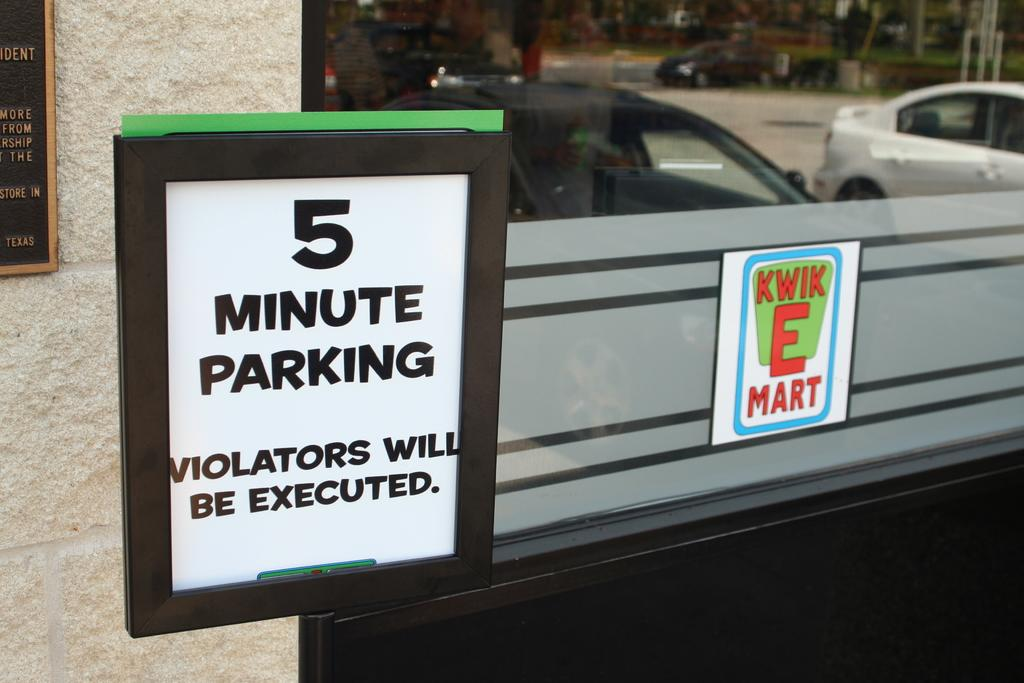What is the main object in the image? There is a board in the image. What else can be seen in the background? There is a wall in the image. What object is used for drinking? There is a glass in the image. What can be seen reflected in the glass? The glass reflects cars on the road. What type of orange tree can be seen growing on the wall in the image? There is no orange tree present in the image; the wall is a separate object from the board and glass. 